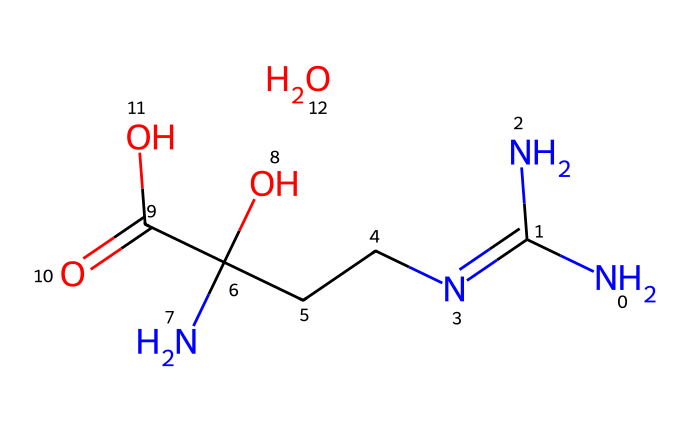What is the molecular formula of this compound? The SMILES representation provides the molecular structure of creatine monohydrate. By analyzing the components, we can identify that it includes carbon (C), hydrogen (H), nitrogen (N), and oxygen (O) atoms. Counting these from the SMILES yields C4H9N3O2.
Answer: C4H9N3O2 How many nitrogen atoms are present in the structure? The SMILES shows 'N' multiple times. By counting, we see there are three nitrogen atoms in the entire structure of creatine monohydrate.
Answer: 3 What functional groups are present in this molecule? From the structure represented in the SMILES, we can identify amine (due to nitrogen groups) and carboxylic acid (due to the -COOH group). The presence of nitrogen implies it also has amines, while the carbonyl and hydroxyl indicates a carboxylic acid group.
Answer: amine and carboxylic acid Is this compound soluble in water? Creatine monohydrate, as represented in its chemical structure, contains polar functional groups (such as -OH from the carboxylic acid), which typically indicates it can interact with water molecules, thus making it soluble.
Answer: soluble What is the primary use of this molecule for athletes? Creatine monohydrate is widely recognized in the sports community for its role in enhancing energy availability during high-intensity workouts, promoting muscle strength and performance.
Answer: performance enhancer Does this compound contain any stereocenters? Reviewing the structure, creatine monohydrate does not contain any carbon atoms that are bonded to four different substituents, indicating it has no stereocenters and thus is achiral.
Answer: no What type of reaction is creatine monohydrate likely to undergo due to its functional groups? Given the presence of the carboxylic acid group, creatine can participate in reactions such as esterification with alcohols or peptide bond formation, which are typical reactions for compounds containing carboxylic acids.
Answer: esterification 